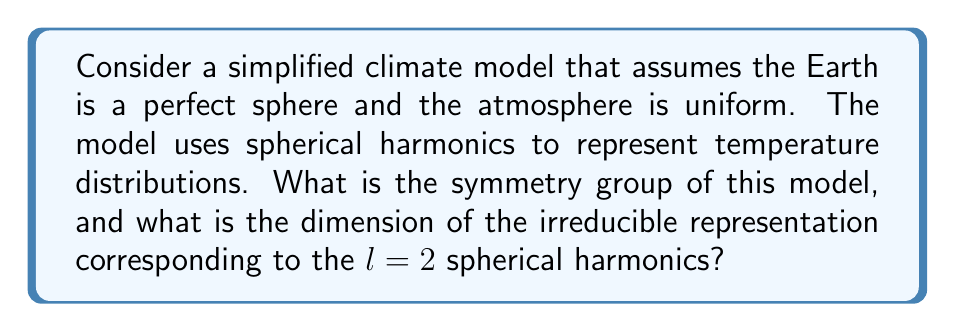Teach me how to tackle this problem. 1. The symmetry group of a sphere with uniform atmosphere is $SO(3)$, the special orthogonal group in three dimensions, which represents all rotations in 3D space.

2. Spherical harmonics are the natural basis functions for representations of $SO(3)$. They are denoted by $Y_l^m(\theta,\phi)$, where $l$ is the degree and $m$ is the order.

3. For a given $l$, the spherical harmonics $Y_l^m$ with $m = -l, -l+1, ..., l-1, l$ form a basis for an irreducible representation of $SO(3)$.

4. The dimension of this irreducible representation is $2l+1$.

5. For $l=2$, we have:
   $$\text{dim} = 2l + 1 = 2(2) + 1 = 5$$

6. This means that for $l=2$, we have five basis functions: $Y_2^{-2}, Y_2^{-1}, Y_2^0, Y_2^1, Y_2^2$.

7. These five functions transform among themselves under rotations, forming a 5-dimensional irreducible representation of $SO(3)$.

Note: As a climatologist skeptical of predictive modeling, it's important to recognize that while this symmetry analysis is mathematically rigorous, real-world climate systems are far more complex and may not adhere strictly to these idealized symmetries.
Answer: $SO(3)$; 5 